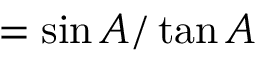<formula> <loc_0><loc_0><loc_500><loc_500>= { \sin A / \tan A }</formula> 